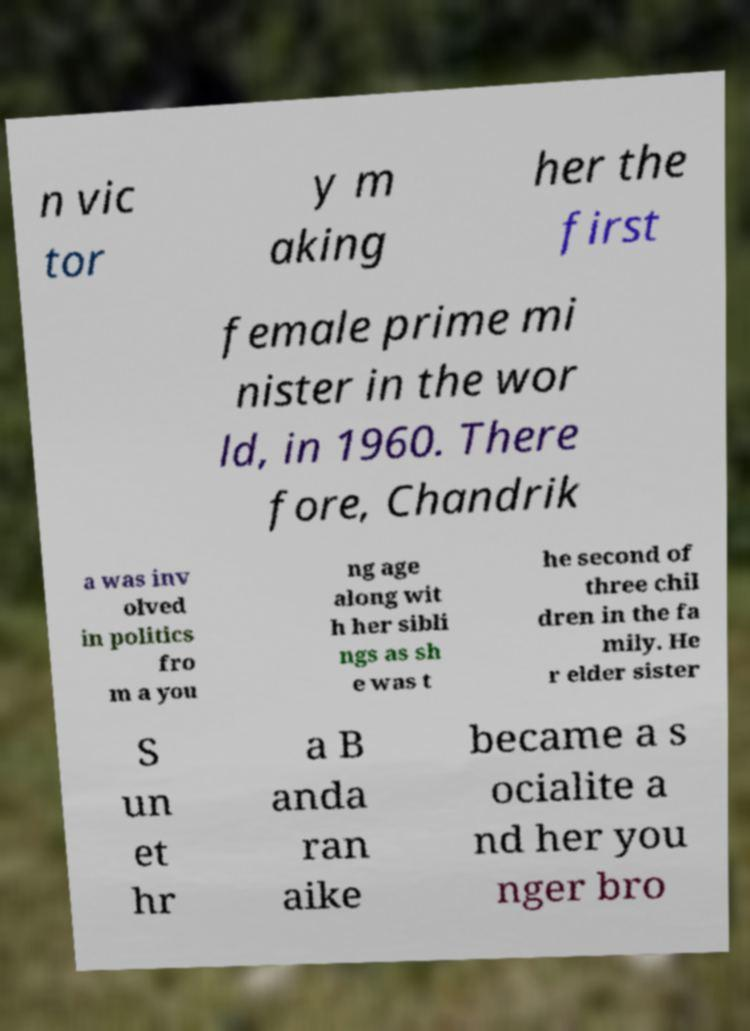There's text embedded in this image that I need extracted. Can you transcribe it verbatim? n vic tor y m aking her the first female prime mi nister in the wor ld, in 1960. There fore, Chandrik a was inv olved in politics fro m a you ng age along wit h her sibli ngs as sh e was t he second of three chil dren in the fa mily. He r elder sister S un et hr a B anda ran aike became a s ocialite a nd her you nger bro 